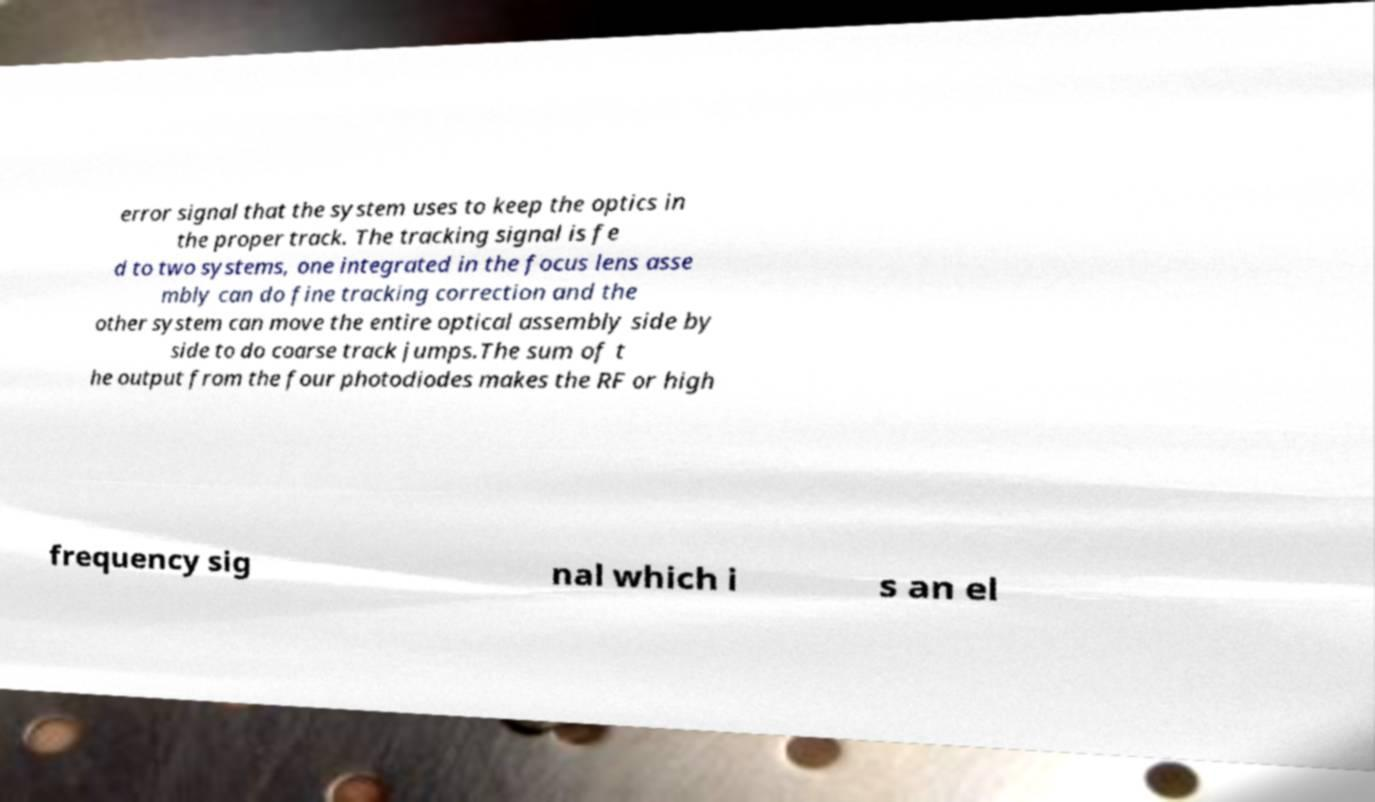Can you accurately transcribe the text from the provided image for me? error signal that the system uses to keep the optics in the proper track. The tracking signal is fe d to two systems, one integrated in the focus lens asse mbly can do fine tracking correction and the other system can move the entire optical assembly side by side to do coarse track jumps.The sum of t he output from the four photodiodes makes the RF or high frequency sig nal which i s an el 